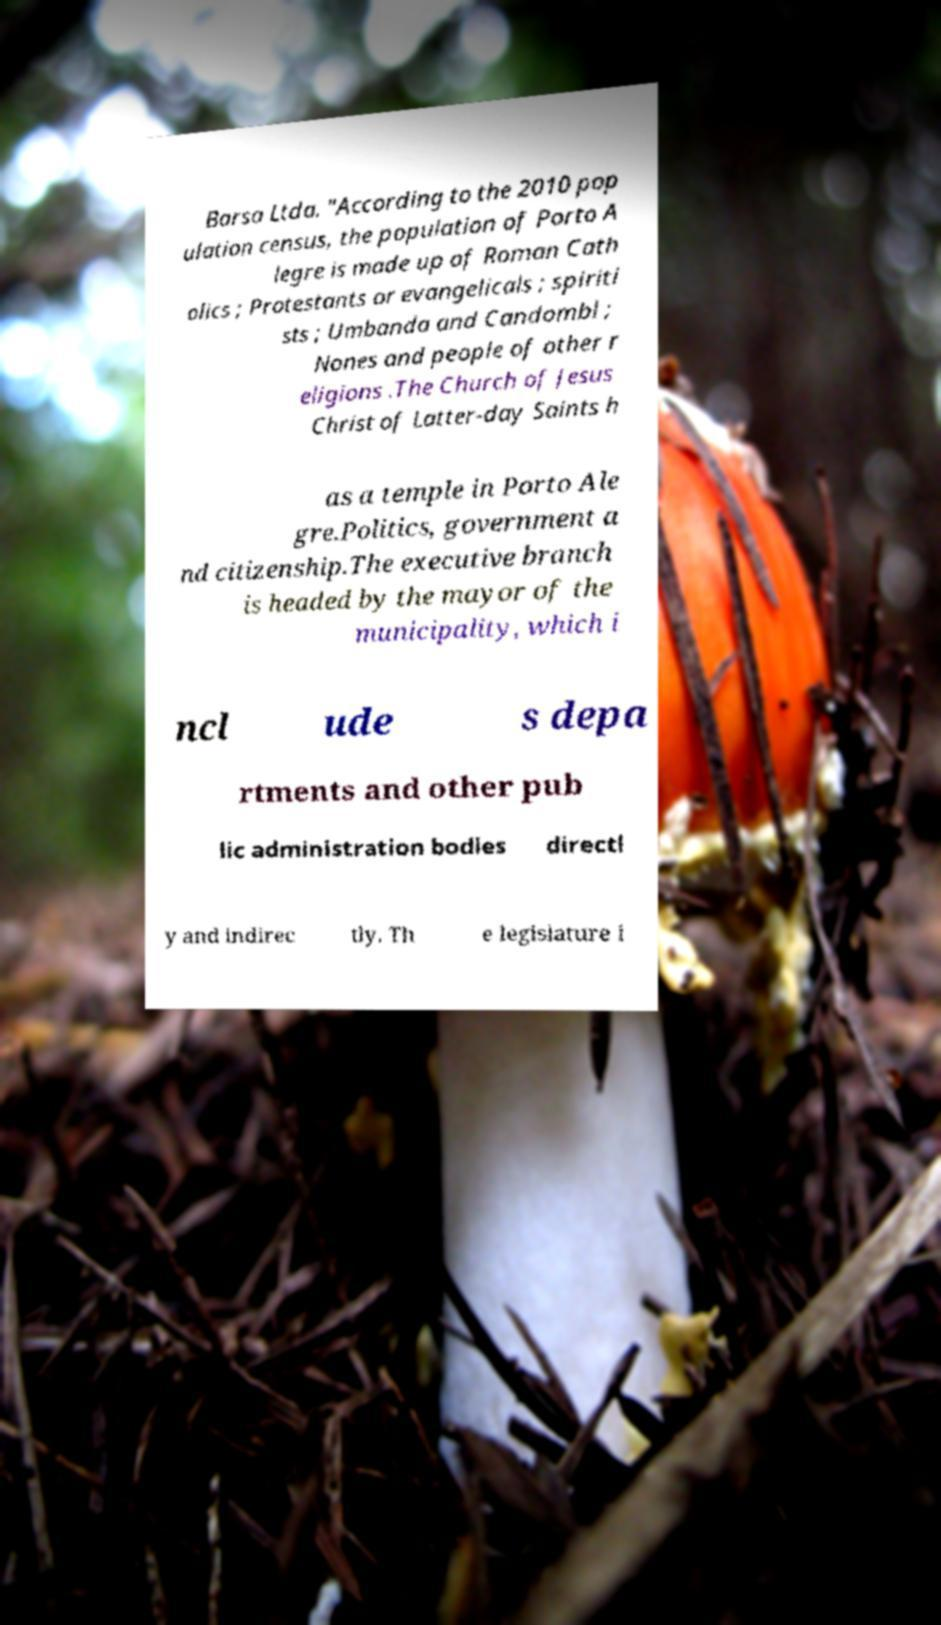For documentation purposes, I need the text within this image transcribed. Could you provide that? Barsa Ltda. "According to the 2010 pop ulation census, the population of Porto A legre is made up of Roman Cath olics ; Protestants or evangelicals ; spiriti sts ; Umbanda and Candombl ; Nones and people of other r eligions .The Church of Jesus Christ of Latter-day Saints h as a temple in Porto Ale gre.Politics, government a nd citizenship.The executive branch is headed by the mayor of the municipality, which i ncl ude s depa rtments and other pub lic administration bodies directl y and indirec tly. Th e legislature i 